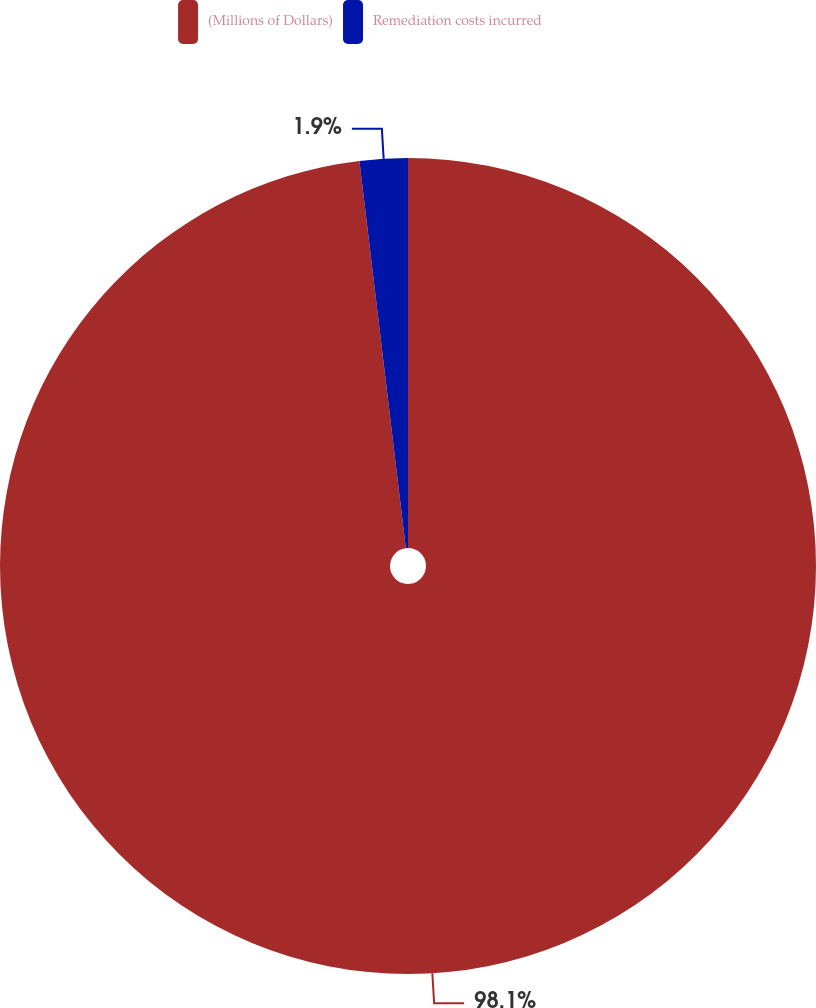<chart> <loc_0><loc_0><loc_500><loc_500><pie_chart><fcel>(Millions of Dollars)<fcel>Remediation costs incurred<nl><fcel>98.1%<fcel>1.9%<nl></chart> 